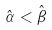<formula> <loc_0><loc_0><loc_500><loc_500>\hat { \alpha } < \hat { \beta }</formula> 